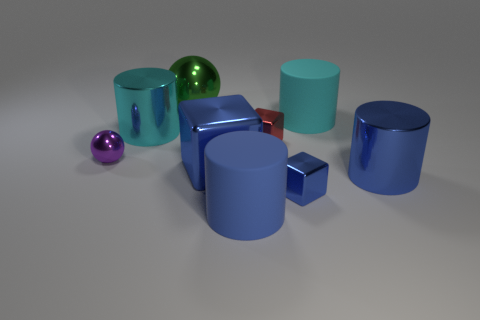What number of large things have the same material as the big ball?
Your answer should be very brief. 3. What is the size of the cyan object left of the tiny metal cube that is behind the tiny purple object?
Provide a short and direct response. Large. Is there a yellow metallic thing of the same shape as the tiny red metallic thing?
Keep it short and to the point. No. There is a matte cylinder that is on the left side of the small blue shiny object; is its size the same as the matte cylinder behind the purple shiny object?
Keep it short and to the point. Yes. Is the number of large metallic blocks that are on the right side of the red thing less than the number of tiny shiny objects in front of the purple shiny ball?
Offer a very short reply. Yes. There is another block that is the same color as the large metallic block; what is its material?
Make the answer very short. Metal. The large shiny cylinder on the left side of the small red object is what color?
Offer a very short reply. Cyan. How many blue cubes are behind the big metallic cylinder that is to the right of the cylinder that is left of the large blue cube?
Make the answer very short. 1. The cyan shiny cylinder has what size?
Your answer should be very brief. Large. There is a green thing that is the same size as the cyan metallic cylinder; what material is it?
Provide a succinct answer. Metal. 